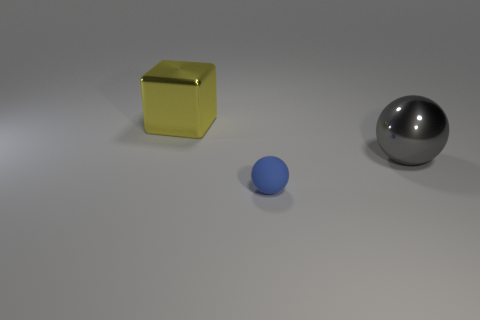Add 1 yellow blocks. How many objects exist? 4 Subtract all spheres. How many objects are left? 1 Add 2 metal cubes. How many metal cubes exist? 3 Subtract 0 cyan blocks. How many objects are left? 3 Subtract all yellow objects. Subtract all metallic balls. How many objects are left? 1 Add 2 small matte balls. How many small matte balls are left? 3 